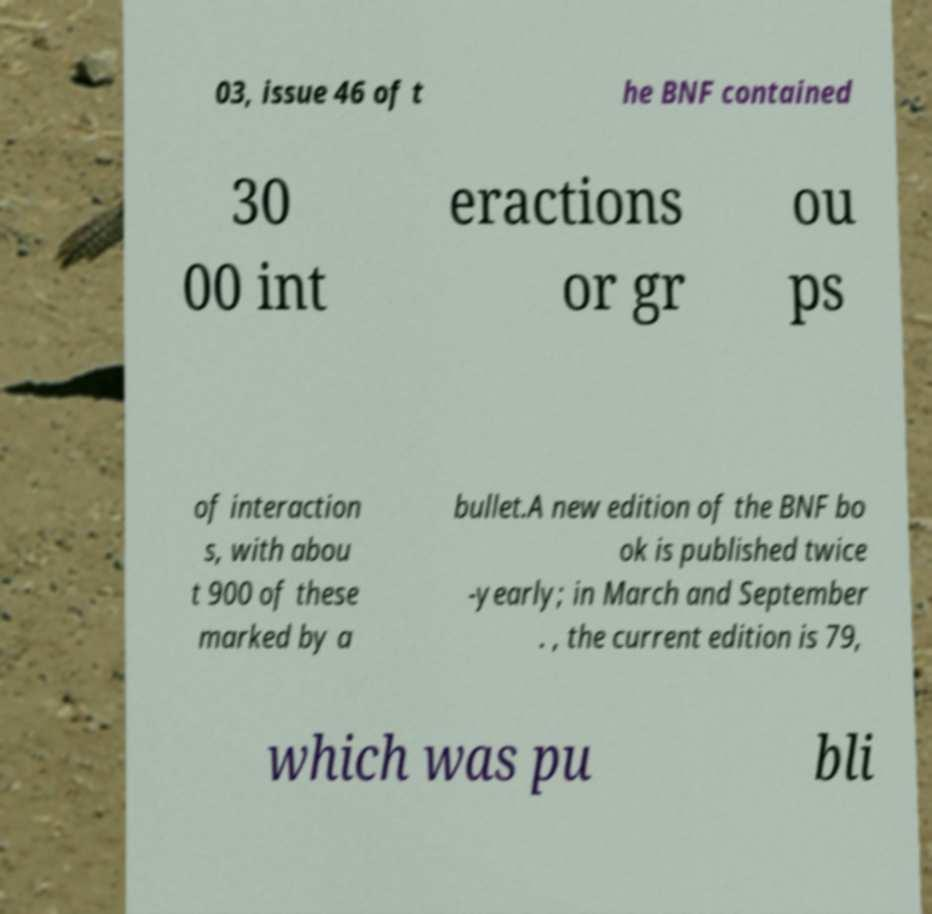I need the written content from this picture converted into text. Can you do that? 03, issue 46 of t he BNF contained 30 00 int eractions or gr ou ps of interaction s, with abou t 900 of these marked by a bullet.A new edition of the BNF bo ok is published twice -yearly; in March and September . , the current edition is 79, which was pu bli 